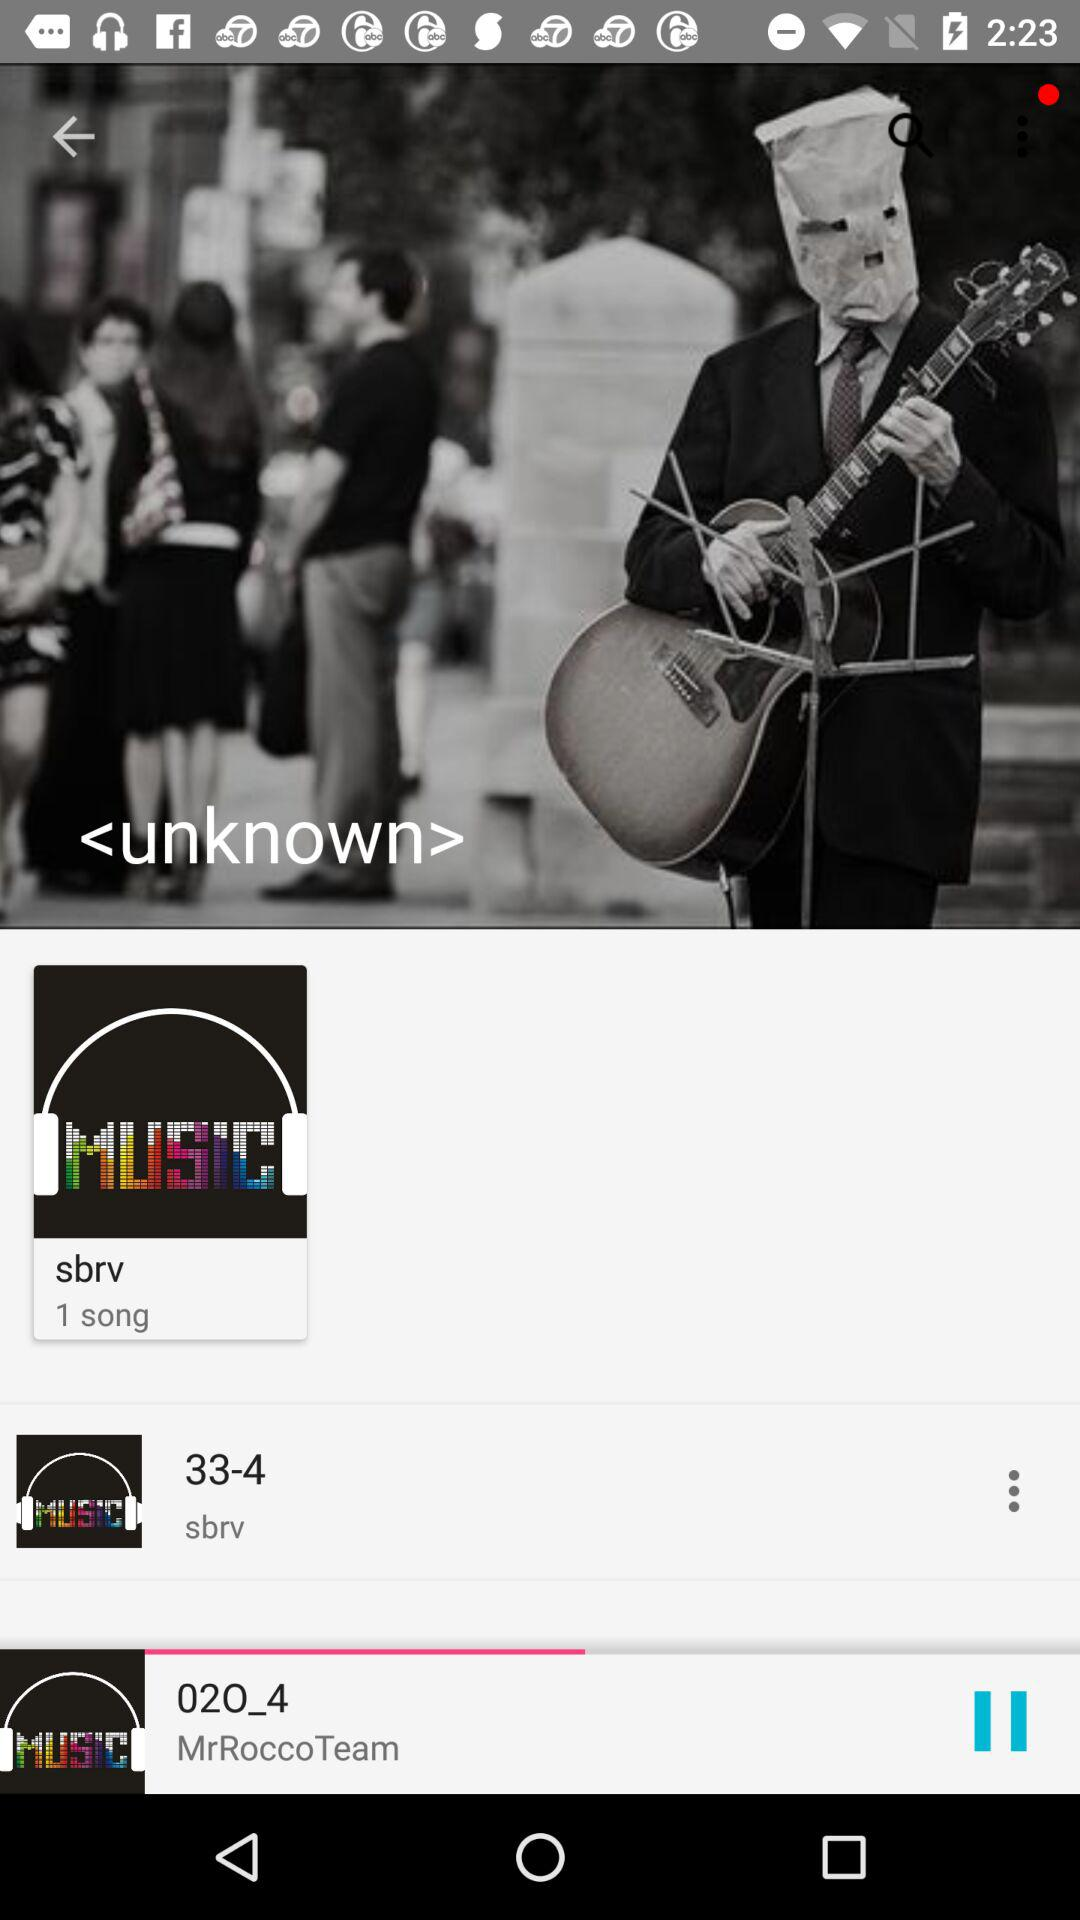Which song is playing? The song playing is 02O_4. 